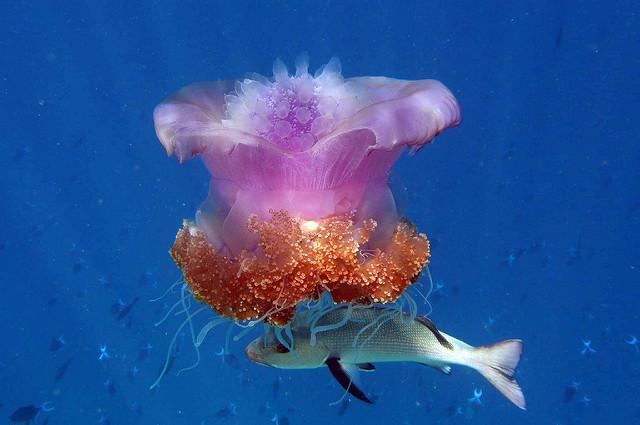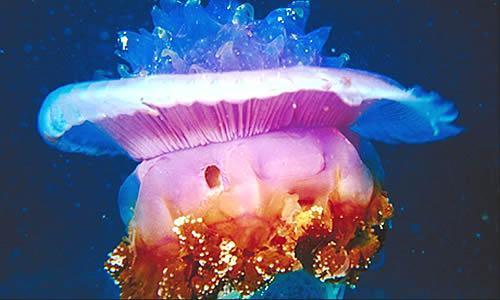The first image is the image on the left, the second image is the image on the right. Evaluate the accuracy of this statement regarding the images: "An image shows a white jellyfish with its 'mushroom cap' heading rightward.". Is it true? Answer yes or no. No. The first image is the image on the left, the second image is the image on the right. Evaluate the accuracy of this statement regarding the images: "A single white jellyfish is traveling towards the right in one of the images.". Is it true? Answer yes or no. No. 